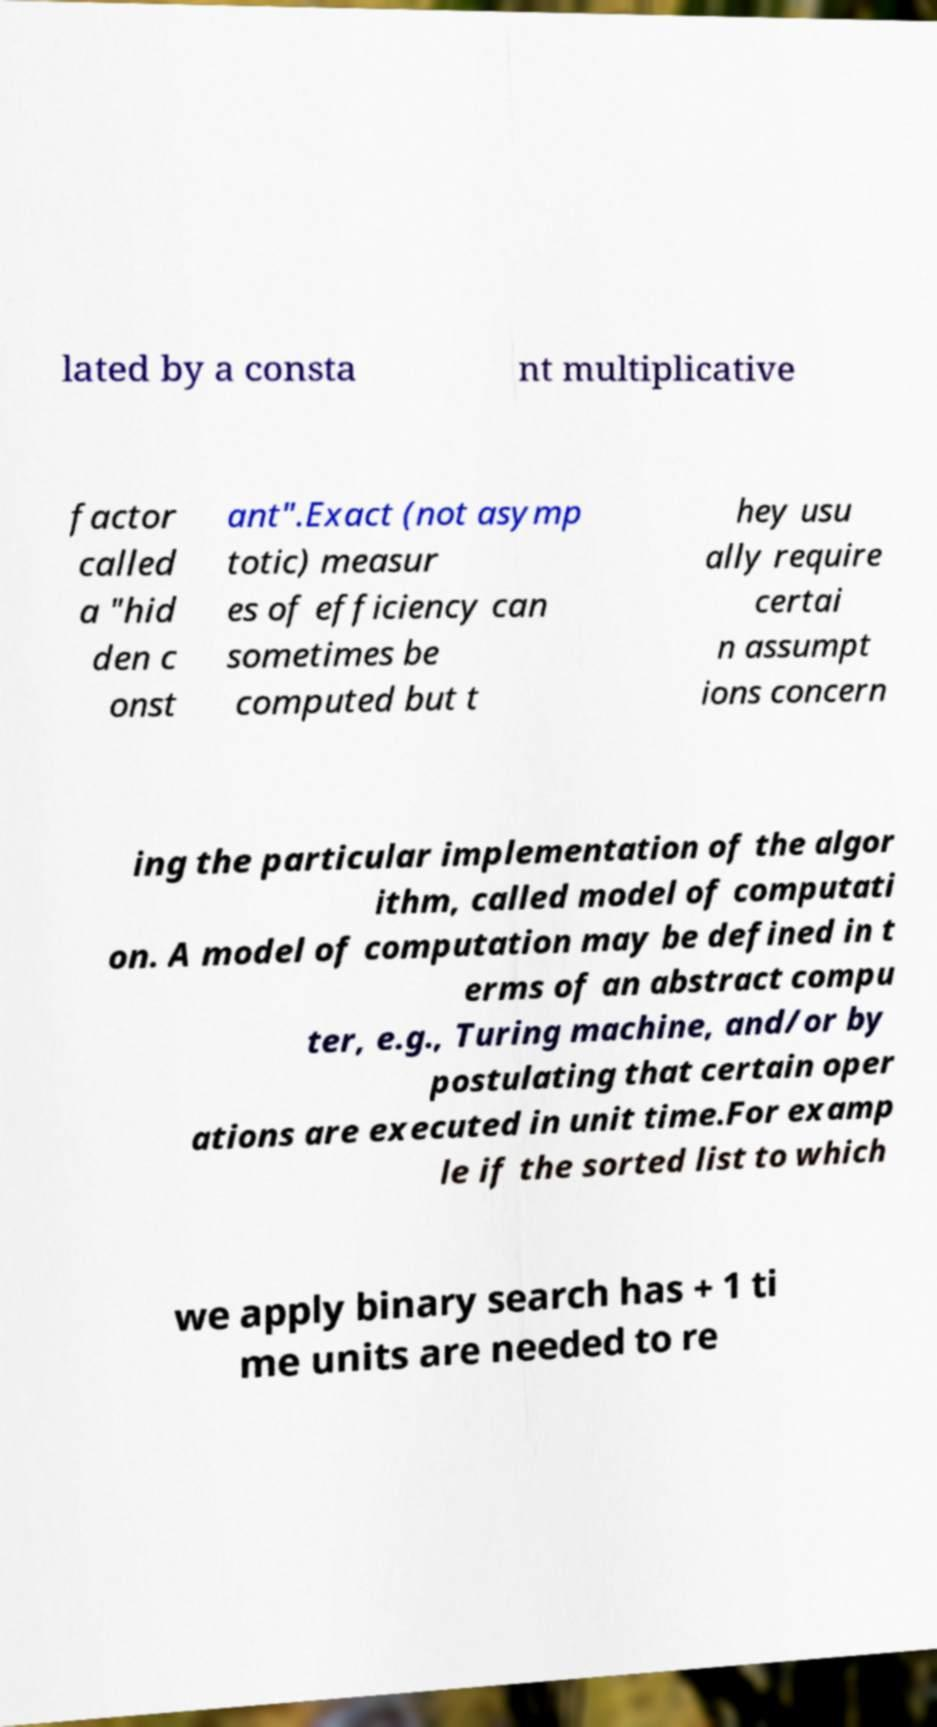For documentation purposes, I need the text within this image transcribed. Could you provide that? lated by a consta nt multiplicative factor called a "hid den c onst ant".Exact (not asymp totic) measur es of efficiency can sometimes be computed but t hey usu ally require certai n assumpt ions concern ing the particular implementation of the algor ithm, called model of computati on. A model of computation may be defined in t erms of an abstract compu ter, e.g., Turing machine, and/or by postulating that certain oper ations are executed in unit time.For examp le if the sorted list to which we apply binary search has + 1 ti me units are needed to re 